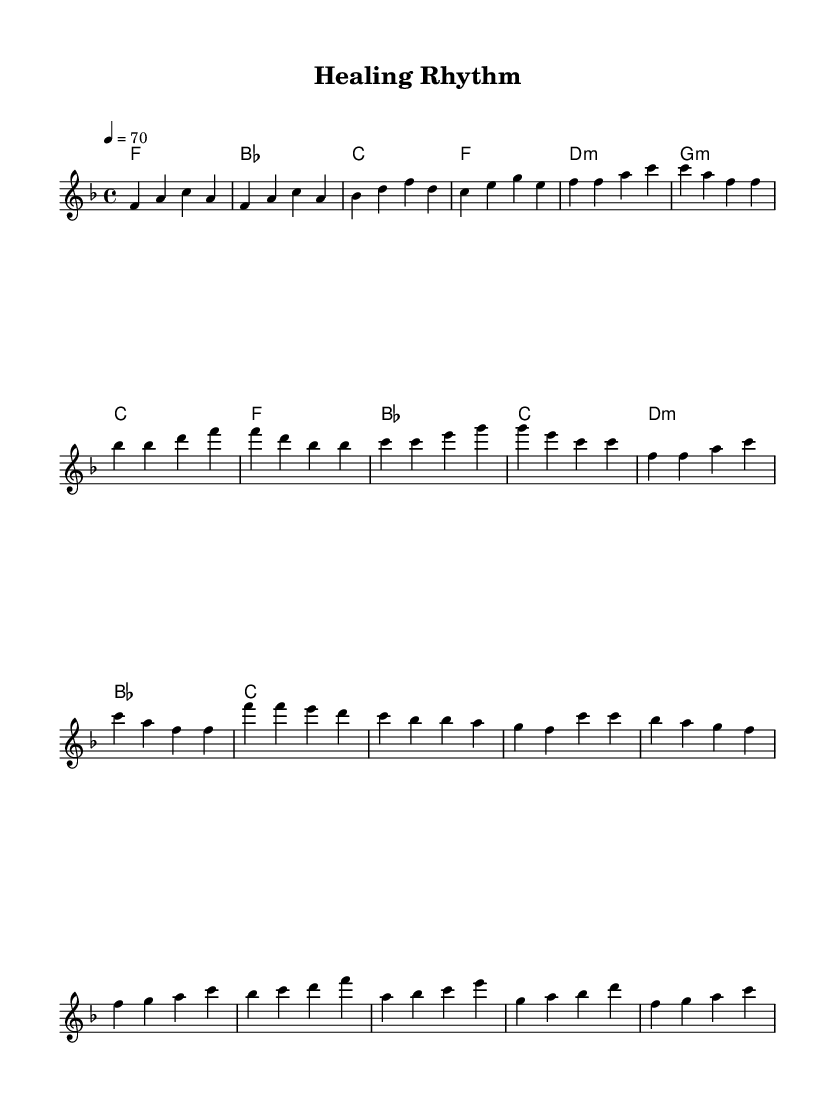What is the key signature of this music? The key signature is F major, which has one flat (B flat). This can be identified in the key signature section of the sheet music, mentioned at the beginning of the global settings.
Answer: F major What is the time signature of this music? The time signature is 4/4, which means there are four beats in each measure and the quarter note gets one beat. This is indicated in the global section within the time signature definition.
Answer: 4/4 What is the tempo marking of this music? The indicated tempo is 70 beats per minute, which is noted at the beginning of the global settings with the marking "4 = 70". This means that the quarter note (4) should be played at a speed of 70 beats per minute.
Answer: 70 How many measures are in the verse section? In the verse section, there are 8 measures. This can be counted from the melody part, where the verse consists of 4 phrases of 2 measures each.
Answer: 8 What is the first note of the chorus? The first note of the chorus is F. This can be seen in the melody section, where the chorus starts with F4 in the first measure of that section.
Answer: F What chords are used in the bridge section? The chords in the bridge section are B flat, C, D minor, F, A, B flat, and C. This can be determined by looking at the harmonies part during the measures designated for the bridge.
Answer: B flat, C, D minor, F, A, B flat, C What musical form does this piece exhibit? The piece exhibits a verse-chorus structure, where the verse is followed by a chorus and then a bridge, this shows a typical layout found in disco music, which often emphasizes the emotional messages of the verses.
Answer: Verse-Chorus 